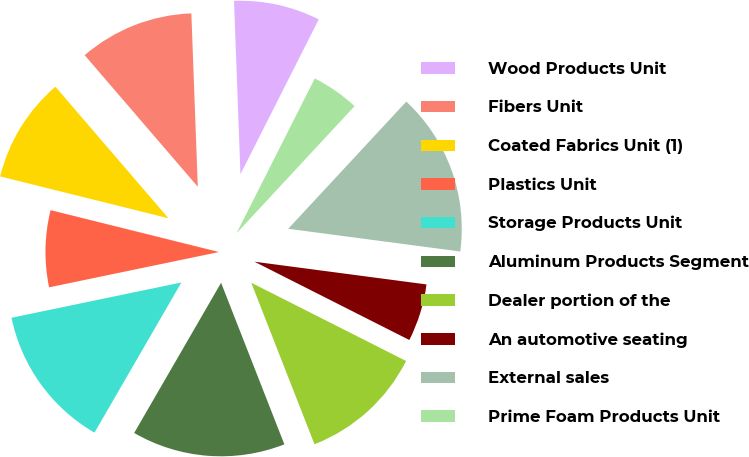Convert chart. <chart><loc_0><loc_0><loc_500><loc_500><pie_chart><fcel>Wood Products Unit<fcel>Fibers Unit<fcel>Coated Fabrics Unit (1)<fcel>Plastics Unit<fcel>Storage Products Unit<fcel>Aluminum Products Segment<fcel>Dealer portion of the<fcel>An automotive seating<fcel>External sales<fcel>Prime Foam Products Unit<nl><fcel>8.04%<fcel>10.71%<fcel>9.82%<fcel>7.14%<fcel>13.39%<fcel>14.29%<fcel>11.61%<fcel>5.36%<fcel>15.18%<fcel>4.46%<nl></chart> 